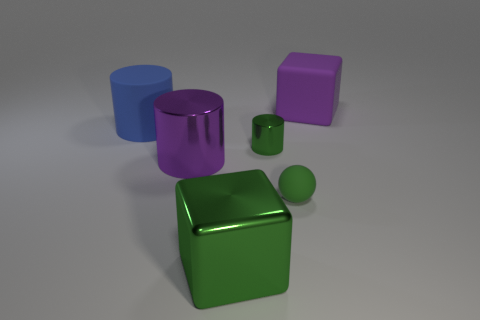There is a big shiny block; is it the same color as the metal cylinder behind the large purple metallic cylinder? While the big shiny block appears to have a reflective surface that might catch colors and lights from its surroundings, its inherent color is distinct and different from that of the metal cylinder behind the large purple metallic cylinder. The big shiny block is green, and the metal cylinder is more of a blueish hue. 